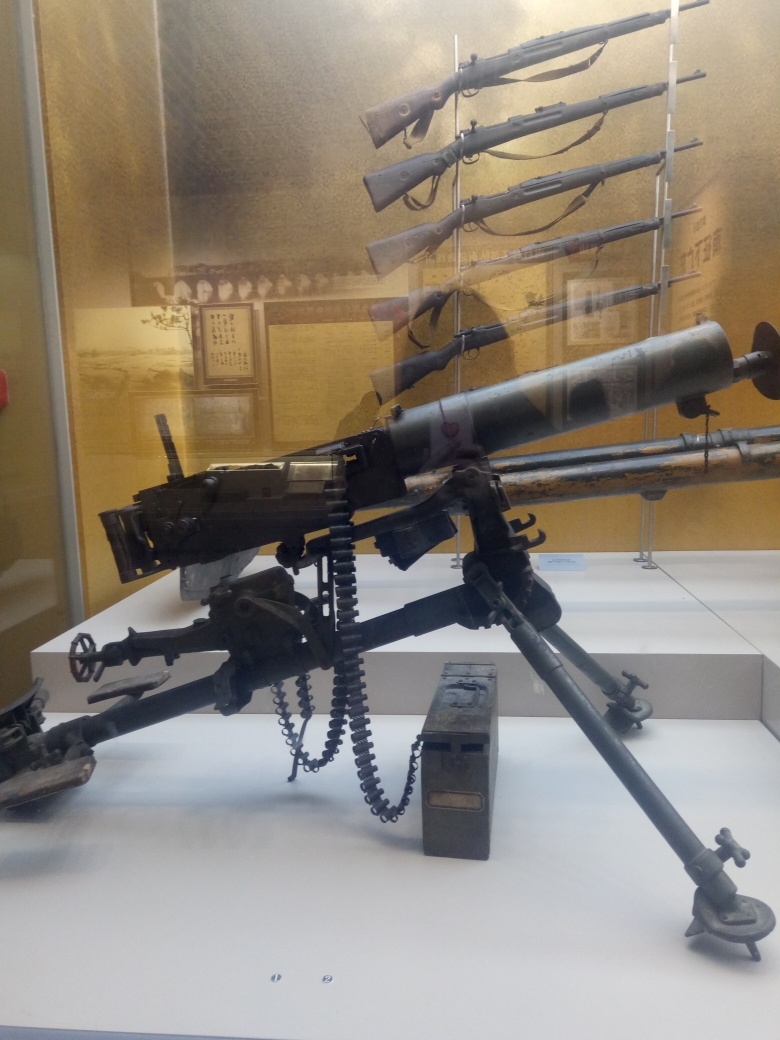Could you describe the technical advancements visible in the firearms shown? Certainly! The machine gun represents a significant leap in firepower capabilities, with the ability to deliver a high volume of bullets in a short amount of time—a revolutionary change from single-load rifles. Its belt-fed mechanism allows for continuous firing, a dramatic contrast to the earlier rifles that required manual reloading after each shot. The development of cooling systems, like the finned barrel seen here, was crucial in enabling sustained fire. The rifles are mounted in a progression that likely demonstrates advancements in loading mechanisms, accuracy, and effective range, reflecting the innovative journey of firearms technology over time. 